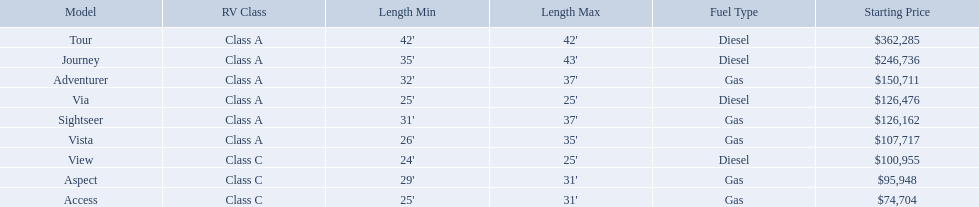What are all the class a models of the winnebago industries? Tour, Journey, Adventurer, Via, Sightseer, Vista. Of those class a models, which has the highest starting price? Tour. Which model has the lowest starting price? Access. Which model has the second most highest starting price? Journey. Which model has the highest price in the winnebago industry? Tour. What are the prices? $362,285, $246,736, $150,711, $126,476, $126,162, $107,717, $100,955, $95,948, $74,704. What is the top price? $362,285. What model has this price? Tour. What is the highest price of a winnebago model? $362,285. What is the name of the vehicle with this price? Tour. 